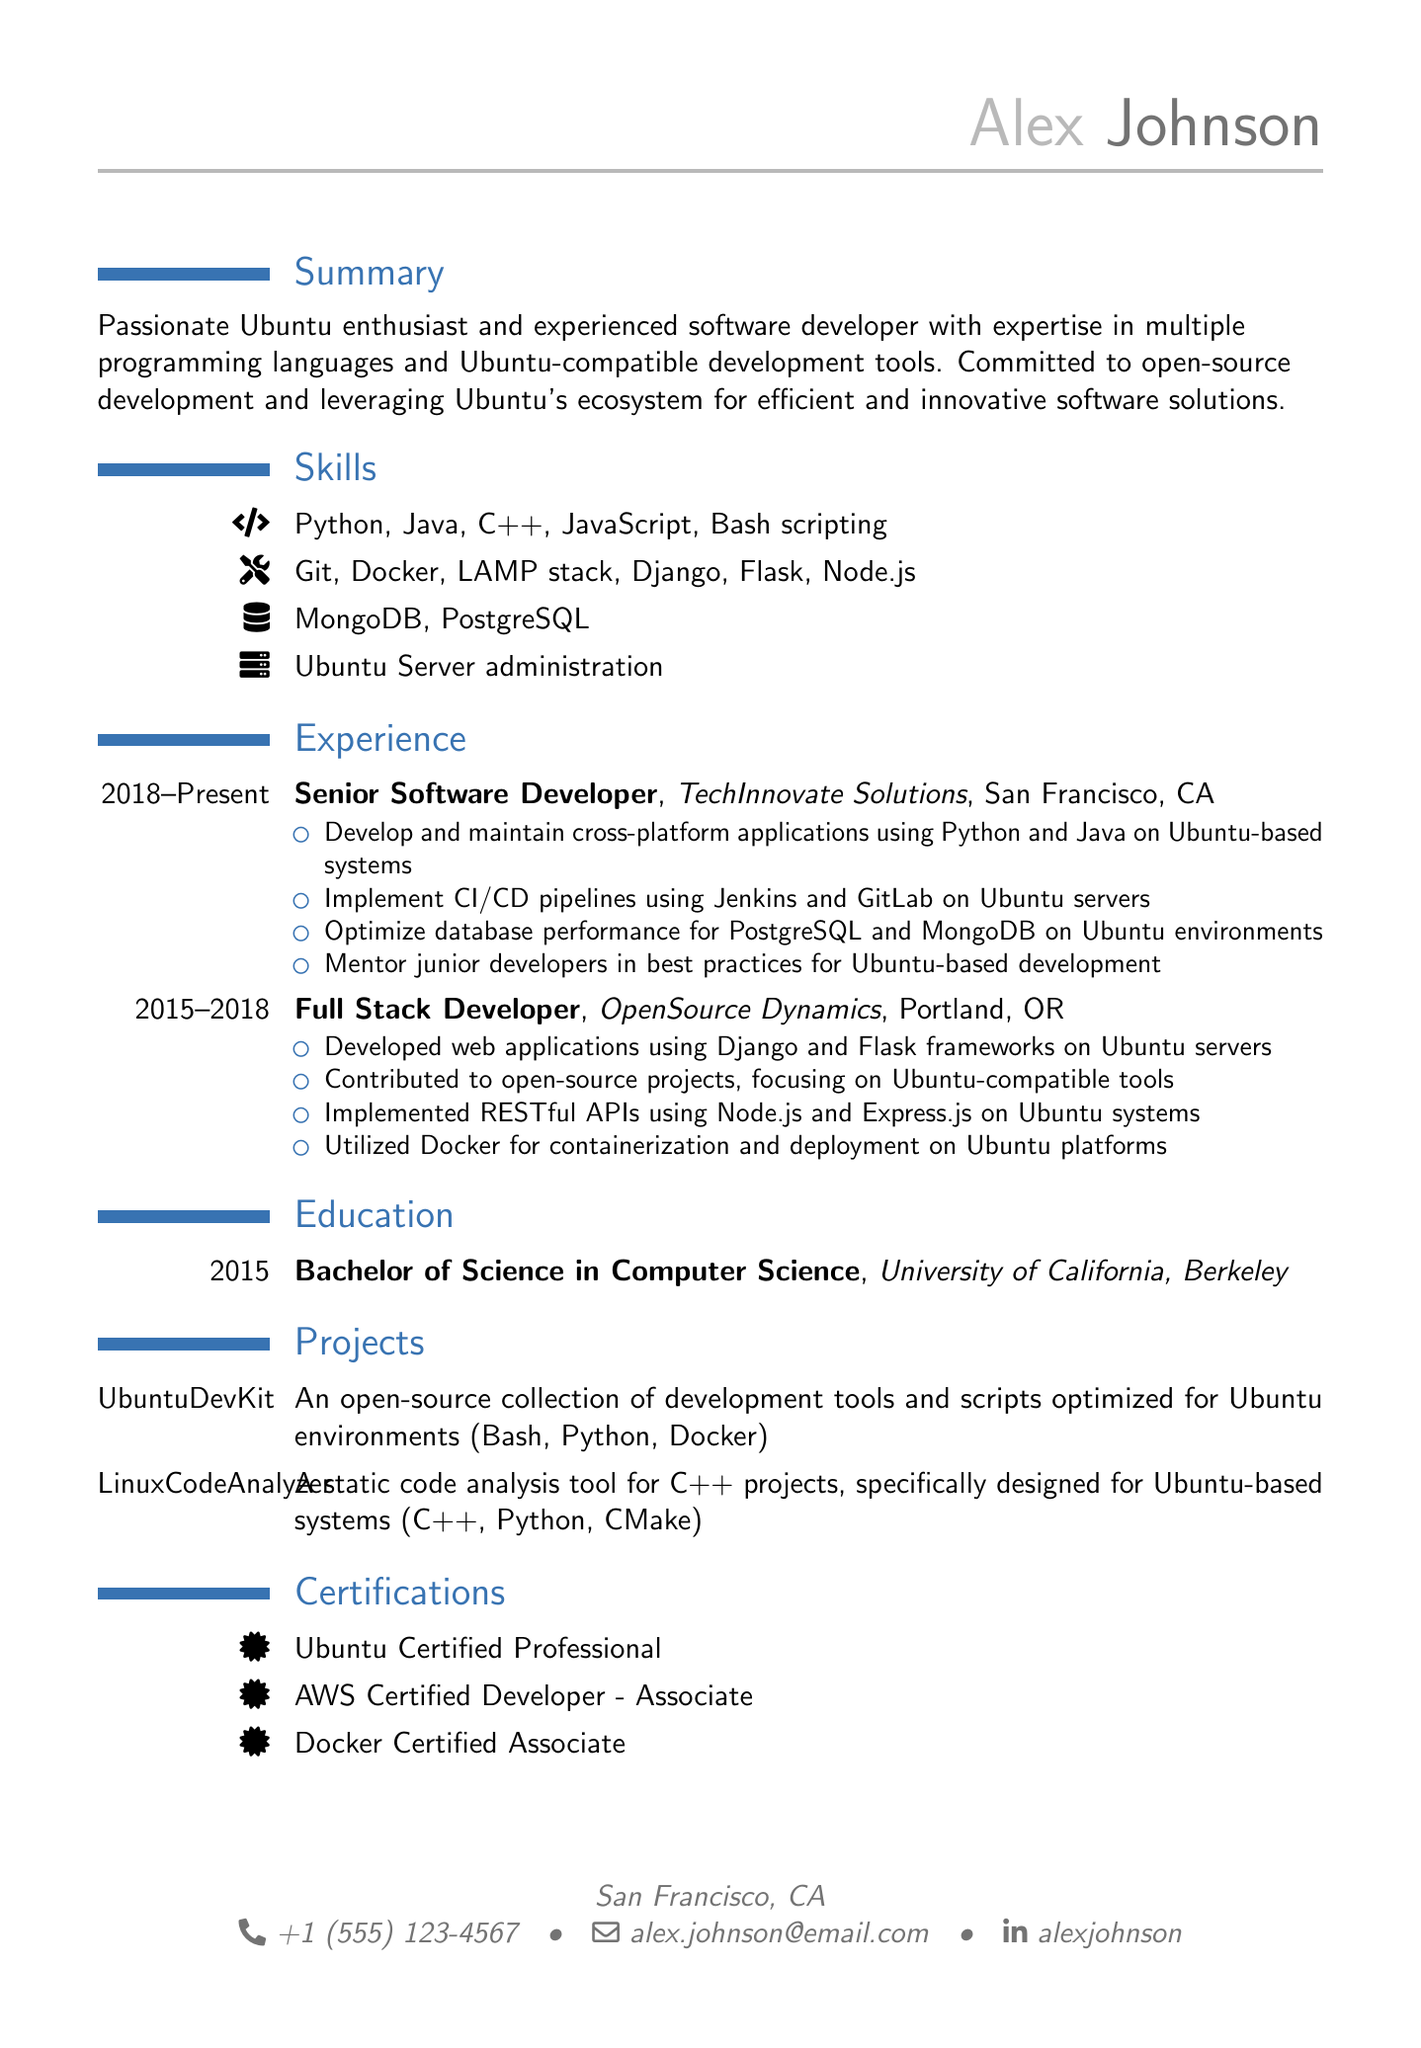what is the name of the individual? The resume showcases the name "Alex Johnson".
Answer: Alex Johnson what is the highest degree obtained? The document states Alex has a Bachelor of Science in Computer Science.
Answer: Bachelor of Science in Computer Science in which year did Alex graduate? The education section indicates that graduation occurred in 2015.
Answer: 2015 what is the title of Alex's current position? The experience section lists the current job title as Senior Software Developer.
Answer: Senior Software Developer which company does Alex currently work for? The resume states that Alex is employed at TechInnovate Solutions.
Answer: TechInnovate Solutions how many years of experience does Alex have in software development? The experience begins in 2015 and continues to the present, giving a total of 8 years.
Answer: 8 years which programming languages is Alex proficient in? The skills section lists several languages including Python, Java, and C++.
Answer: Python, Java, C++ what certification does Alex have that specifically relates to Ubuntu? The resume mentions the Ubuntu Certified Professional certification.
Answer: Ubuntu Certified Professional what types of projects has Alex worked on? Alex has worked on projects like UbuntuDevKit and LinuxCodeAnalyzer, focused on tools for Ubuntu.
Answer: UbuntuDevKit, LinuxCodeAnalyzer what is the duration of Alex's role at OpenSource Dynamics? The experience section shows that Alex worked there from 2015 to 2018, which is 3 years.
Answer: 3 years 